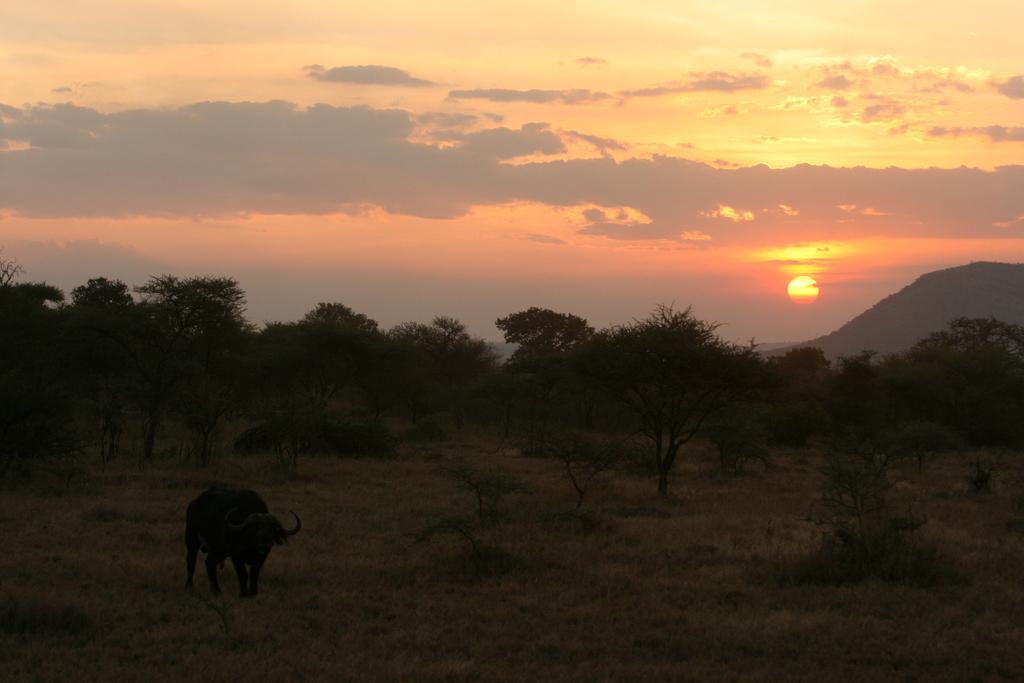Could you give a brief overview of what you see in this image? In this image there is a buffalo on the surface of the grass. In the background there are trees, mountains and the sky. 